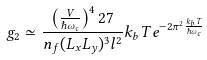Convert formula to latex. <formula><loc_0><loc_0><loc_500><loc_500>g _ { 2 } \simeq \frac { \left ( \frac { V } { \hbar { \omega } _ { c } } \right ) ^ { 4 } 2 7 } { n _ { f } ( L _ { x } L _ { y } ) ^ { 3 } l ^ { 2 } } k _ { b } T e ^ { - 2 \pi ^ { 2 } \frac { k _ { b } T } { \hbar { \omega } _ { c } } }</formula> 